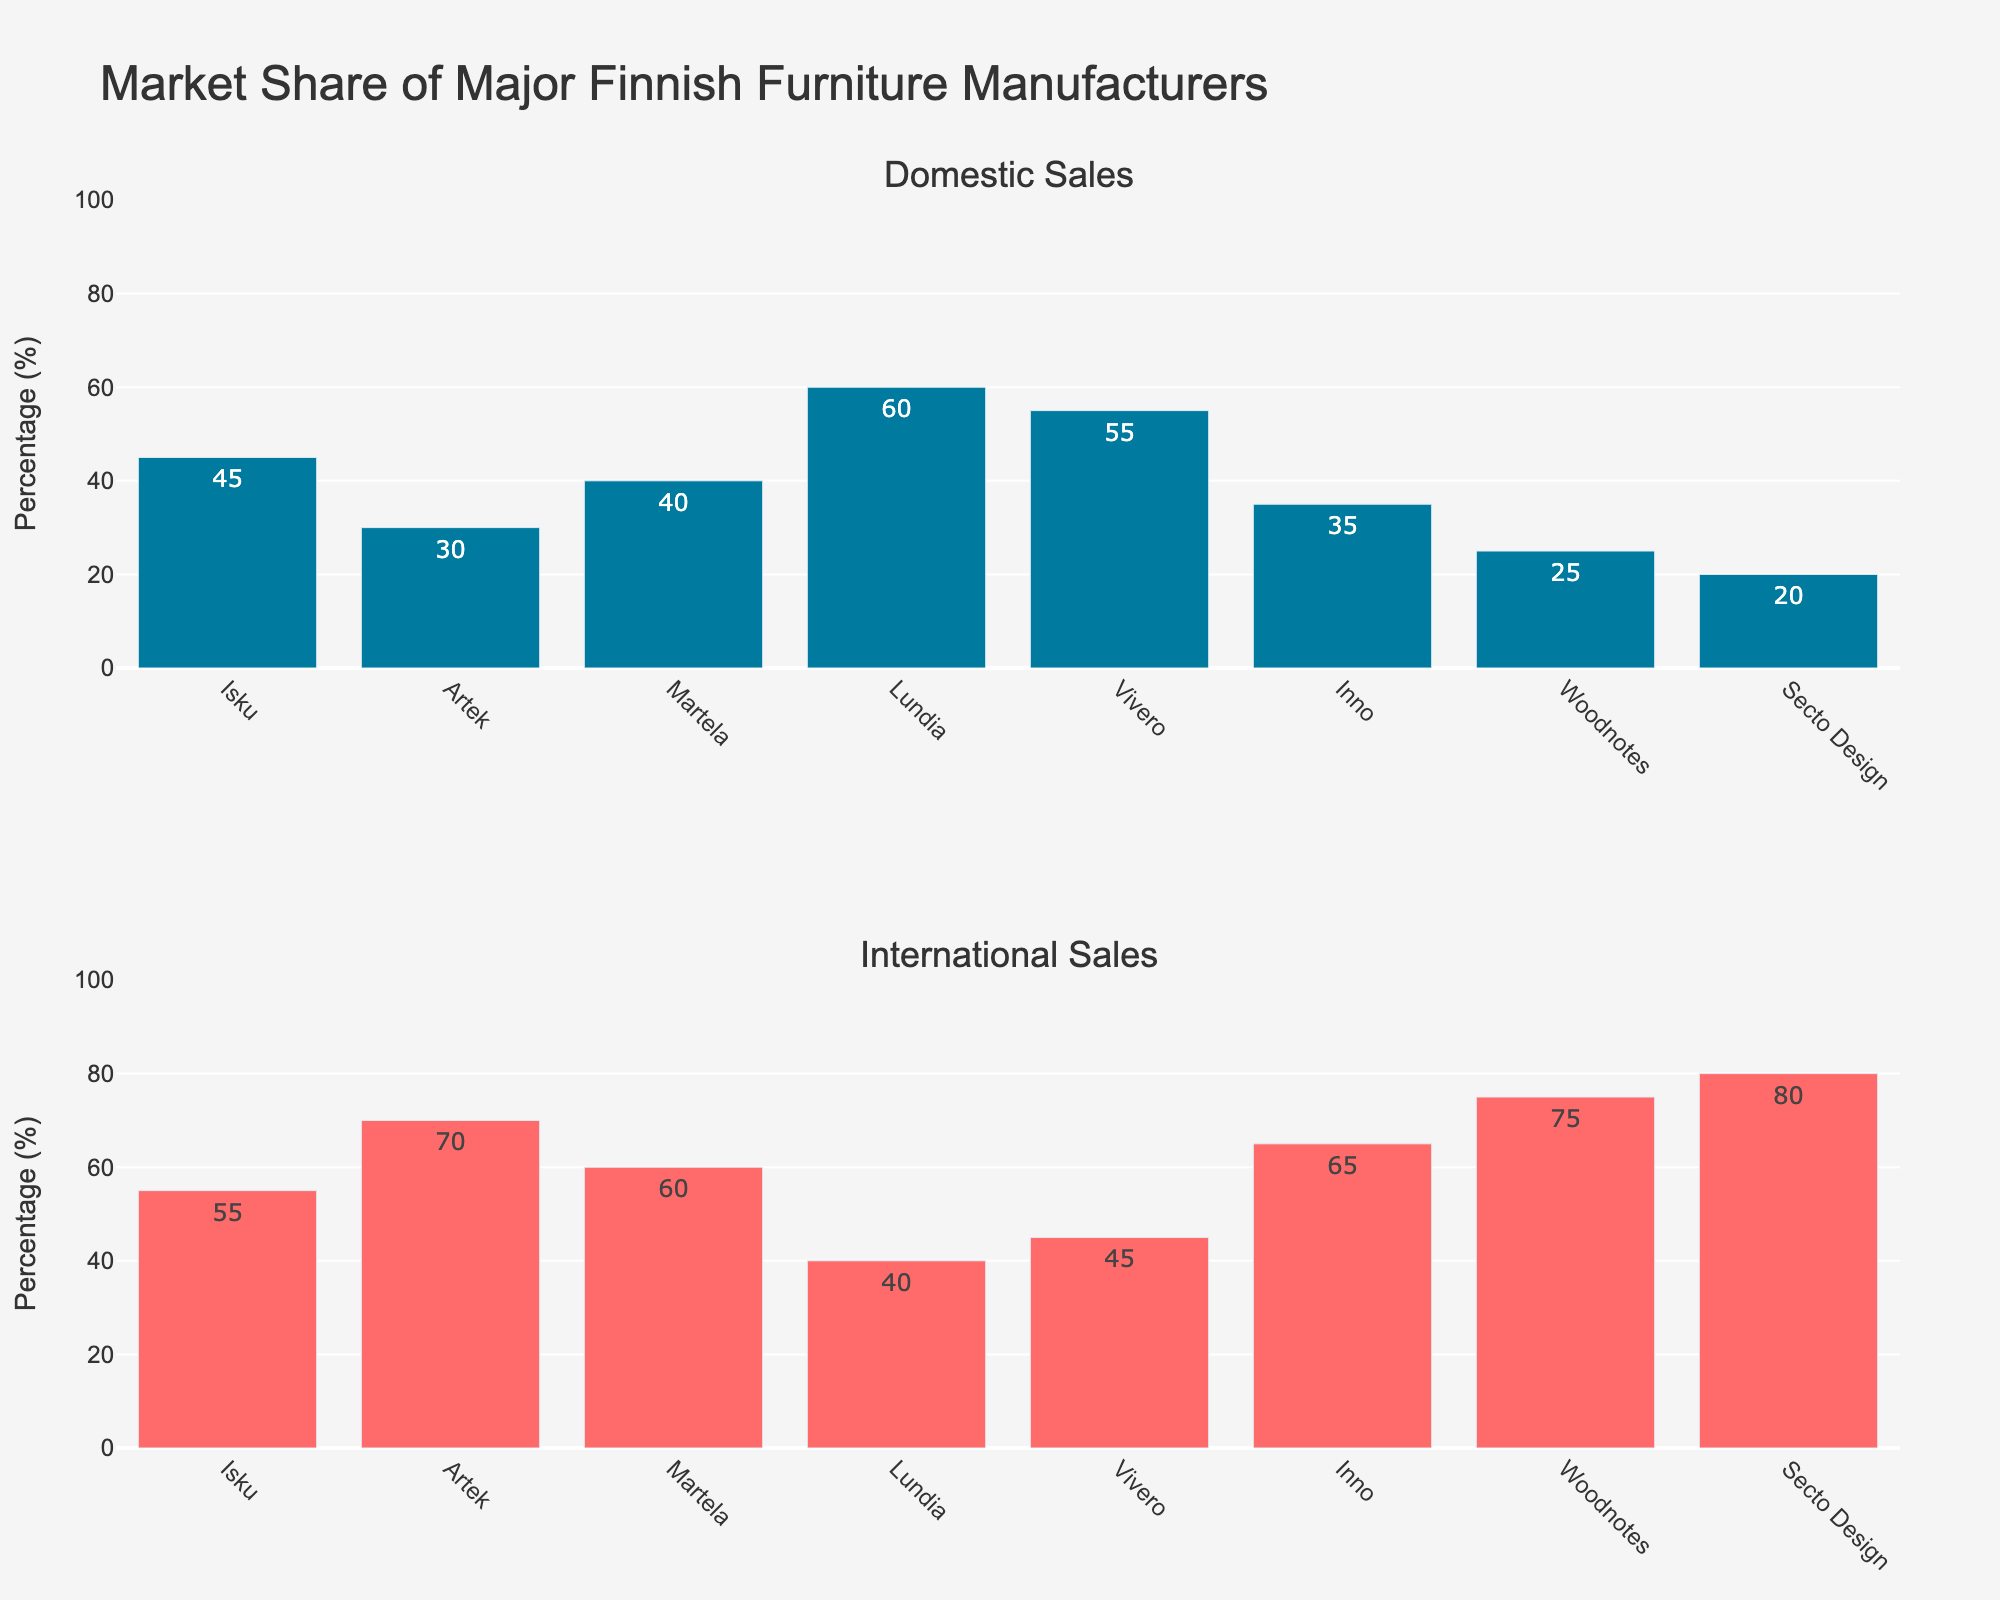What is the highest domestic sales percentage among the manufacturers? Look at the 'Domestic Sales' subplot and identify the highest bar. The bar for Lundia is the tallest.
Answer: Lundia Which manufacturer has the lowest international sales percentage? Look at the 'International Sales' subplot and find the shortest bar. The bar for Lundia is the shortest.
Answer: Lundia How many manufacturers have more than 50% in domestic sales? Identify bars in the 'Domestic Sales' subplot that reach above the 50% mark. Lundia, Vivero, and Isku meet this criterion.
Answer: 3 What is the total percentage of domestic sales for Artek and Secto Design combined? Look at the 'Domestic Sales' subplot and sum the percentages for Artek (30%) and Secto Design (20%).
Answer: 50% What is the difference between domestic and international sales for Woodnotes? Identify the values for Woodnotes in both subplots. Domestic sales are 25%, and international sales are 75%. Subtract the domestic sales percentage from the international sales percentage.
Answer: 50% Which manufacturer has a greater difference between international and domestic sales, Artek or Inno? Calculate the difference for both manufacturers. Artek: 70% - 30% = 40%. Inno: 65% - 35% = 30%.
Answer: Artek Does Martela have more domestic sales or international sales? Compare Martela's domestic sales (40%) with its international sales (60%) from the respective subplots.
Answer: International What is the average domestic sales percentage across all manufacturers? Add up all domestic sales percentages and divide by the number of manufacturers. (45 + 30 + 40 + 60 + 55 + 35 + 25 + 20)/8 = 38.75.
Answer: 38.75% How do domestic sales of Vivero compare to Inno? Compare the heights of the bars for Vivero (55%) and Inno (35%) in the 'Domestic Sales' subplot. Vivero has a higher percentage than Inno.
Answer: Vivero has higher Which manufacturer has the highest international sales percentage? Identify the tallest bar in the 'International Sales' subplot, which is for Secto Design.
Answer: Secto Design 